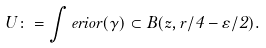Convert formula to latex. <formula><loc_0><loc_0><loc_500><loc_500>U \colon = \int e r i o r ( \gamma ) \subset B ( z , r / 4 - \varepsilon / 2 ) .</formula> 